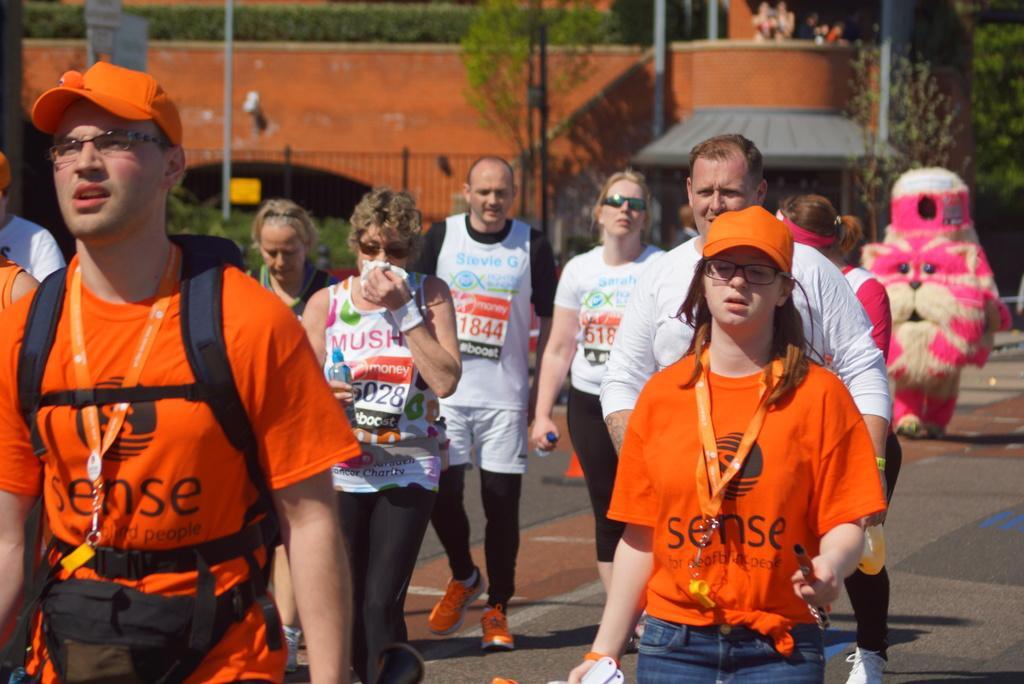How would you summarize this image in a sentence or two? This picture describes about group of people, few people are walking, few wore caps and few people wore spectacles, in the background we can see a building, fence, few trees and poles. 